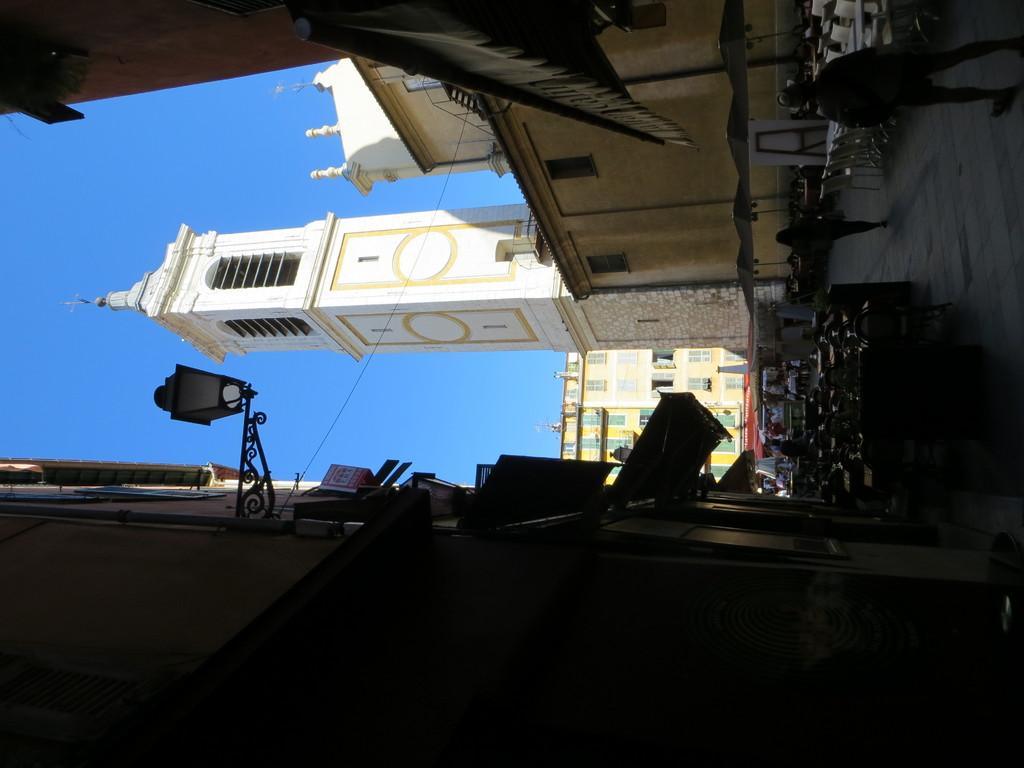In one or two sentences, can you explain what this image depicts? In this picture we can see few buildings, tables, chairs and group of people, on the left side of the image we can see a light. 